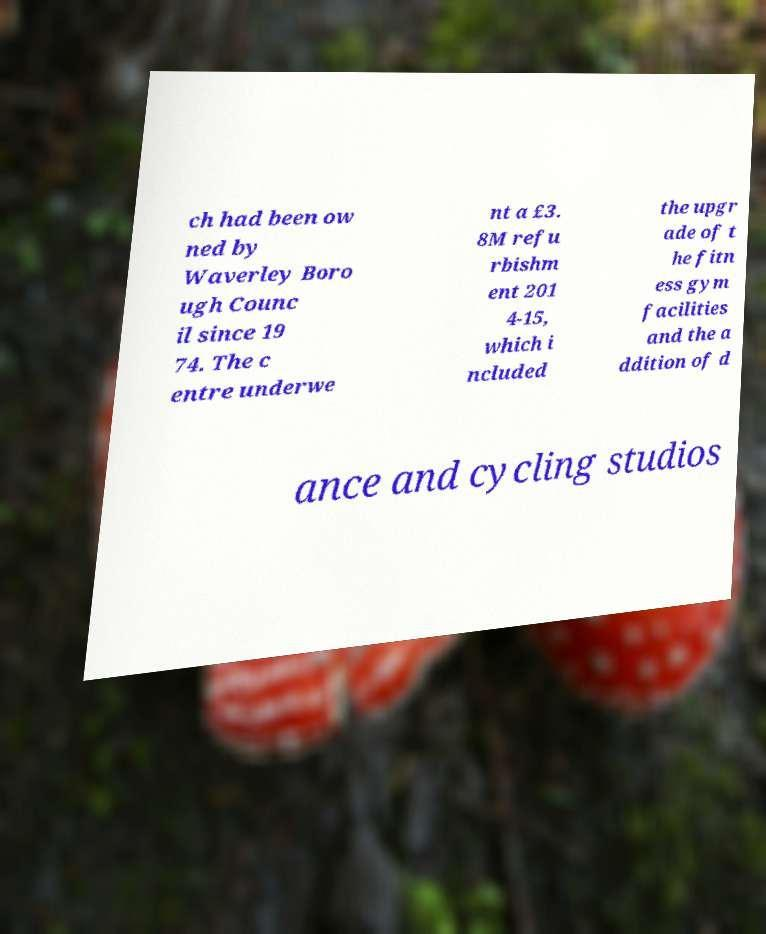Can you accurately transcribe the text from the provided image for me? ch had been ow ned by Waverley Boro ugh Counc il since 19 74. The c entre underwe nt a £3. 8M refu rbishm ent 201 4-15, which i ncluded the upgr ade of t he fitn ess gym facilities and the a ddition of d ance and cycling studios 